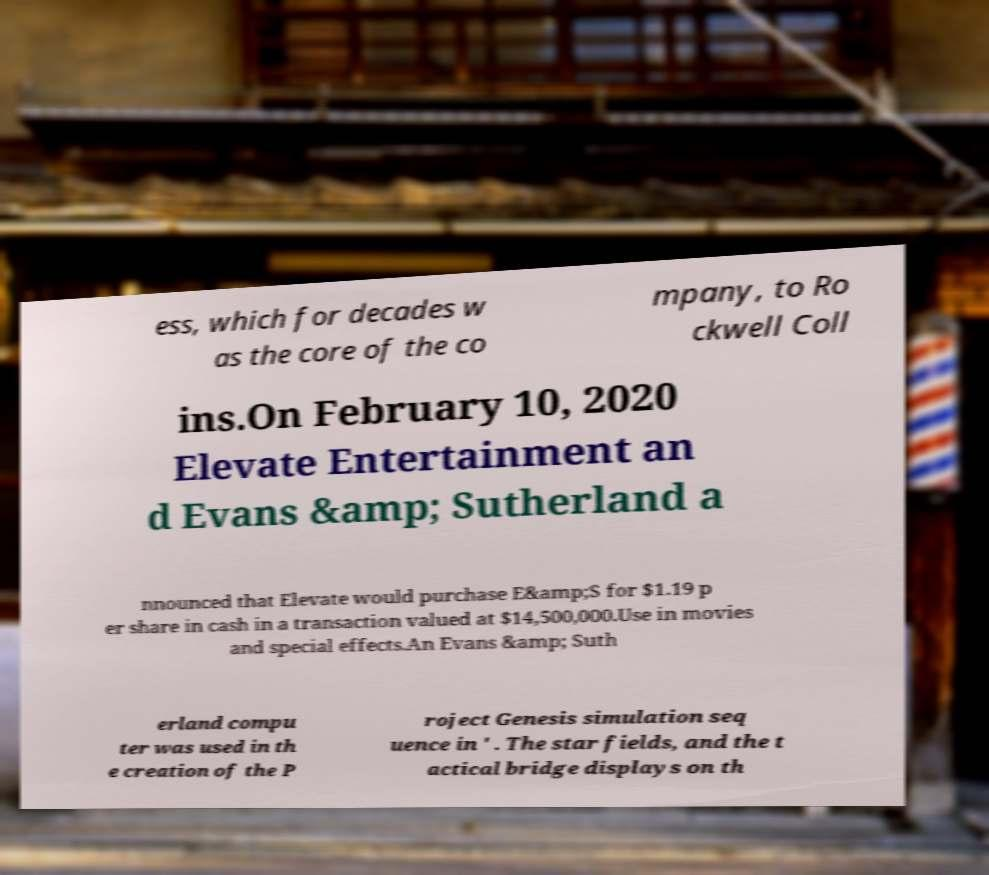Please read and relay the text visible in this image. What does it say? ess, which for decades w as the core of the co mpany, to Ro ckwell Coll ins.On February 10, 2020 Elevate Entertainment an d Evans &amp; Sutherland a nnounced that Elevate would purchase E&amp;S for $1.19 p er share in cash in a transaction valued at $14,500,000.Use in movies and special effects.An Evans &amp; Suth erland compu ter was used in th e creation of the P roject Genesis simulation seq uence in ' . The star fields, and the t actical bridge displays on th 